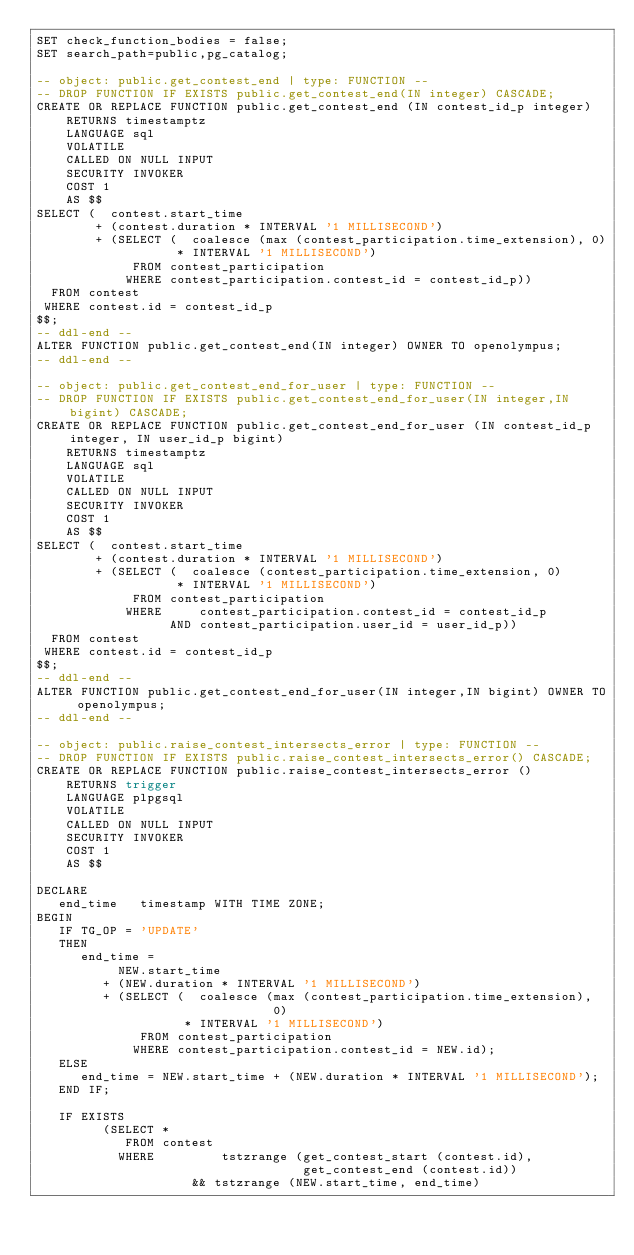<code> <loc_0><loc_0><loc_500><loc_500><_SQL_>SET check_function_bodies = false;
SET search_path=public,pg_catalog;

-- object: public.get_contest_end | type: FUNCTION --
-- DROP FUNCTION IF EXISTS public.get_contest_end(IN integer) CASCADE;
CREATE OR REPLACE FUNCTION public.get_contest_end (IN contest_id_p integer)
	RETURNS timestamptz
	LANGUAGE sql
	VOLATILE
	CALLED ON NULL INPUT
	SECURITY INVOKER
	COST 1
	AS $$
SELECT (  contest.start_time
        + (contest.duration * INTERVAL '1 MILLISECOND')
        + (SELECT (  coalesce (max (contest_participation.time_extension), 0)
                   * INTERVAL '1 MILLISECOND')
             FROM contest_participation
            WHERE contest_participation.contest_id = contest_id_p))
  FROM contest
 WHERE contest.id = contest_id_p
$$;
-- ddl-end --
ALTER FUNCTION public.get_contest_end(IN integer) OWNER TO openolympus;
-- ddl-end --

-- object: public.get_contest_end_for_user | type: FUNCTION --
-- DROP FUNCTION IF EXISTS public.get_contest_end_for_user(IN integer,IN bigint) CASCADE;
CREATE OR REPLACE FUNCTION public.get_contest_end_for_user (IN contest_id_p integer, IN user_id_p bigint)
	RETURNS timestamptz
	LANGUAGE sql
	VOLATILE
	CALLED ON NULL INPUT
	SECURITY INVOKER
	COST 1
	AS $$
SELECT (  contest.start_time
        + (contest.duration * INTERVAL '1 MILLISECOND')
        + (SELECT (  coalesce (contest_participation.time_extension, 0)
                   * INTERVAL '1 MILLISECOND')
             FROM contest_participation
            WHERE     contest_participation.contest_id = contest_id_p
                  AND contest_participation.user_id = user_id_p))
  FROM contest
 WHERE contest.id = contest_id_p
$$;
-- ddl-end --
ALTER FUNCTION public.get_contest_end_for_user(IN integer,IN bigint) OWNER TO openolympus;
-- ddl-end --

-- object: public.raise_contest_intersects_error | type: FUNCTION --
-- DROP FUNCTION IF EXISTS public.raise_contest_intersects_error() CASCADE;
CREATE OR REPLACE FUNCTION public.raise_contest_intersects_error ()
	RETURNS trigger
	LANGUAGE plpgsql
	VOLATILE
	CALLED ON NULL INPUT
	SECURITY INVOKER
	COST 1
	AS $$

DECLARE
   end_time   timestamp WITH TIME ZONE;
BEGIN
   IF TG_OP = 'UPDATE'
   THEN
      end_time =
           NEW.start_time
         + (NEW.duration * INTERVAL '1 MILLISECOND')
         + (SELECT (  coalesce (max (contest_participation.time_extension),
                                0)
                    * INTERVAL '1 MILLISECOND')
              FROM contest_participation
             WHERE contest_participation.contest_id = NEW.id);
   ELSE
      end_time = NEW.start_time + (NEW.duration * INTERVAL '1 MILLISECOND');
   END IF;

   IF EXISTS
         (SELECT *
            FROM contest
           WHERE         tstzrange (get_contest_start (contest.id),
                                    get_contest_end (contest.id))
                     && tstzrange (NEW.start_time, end_time)</code> 